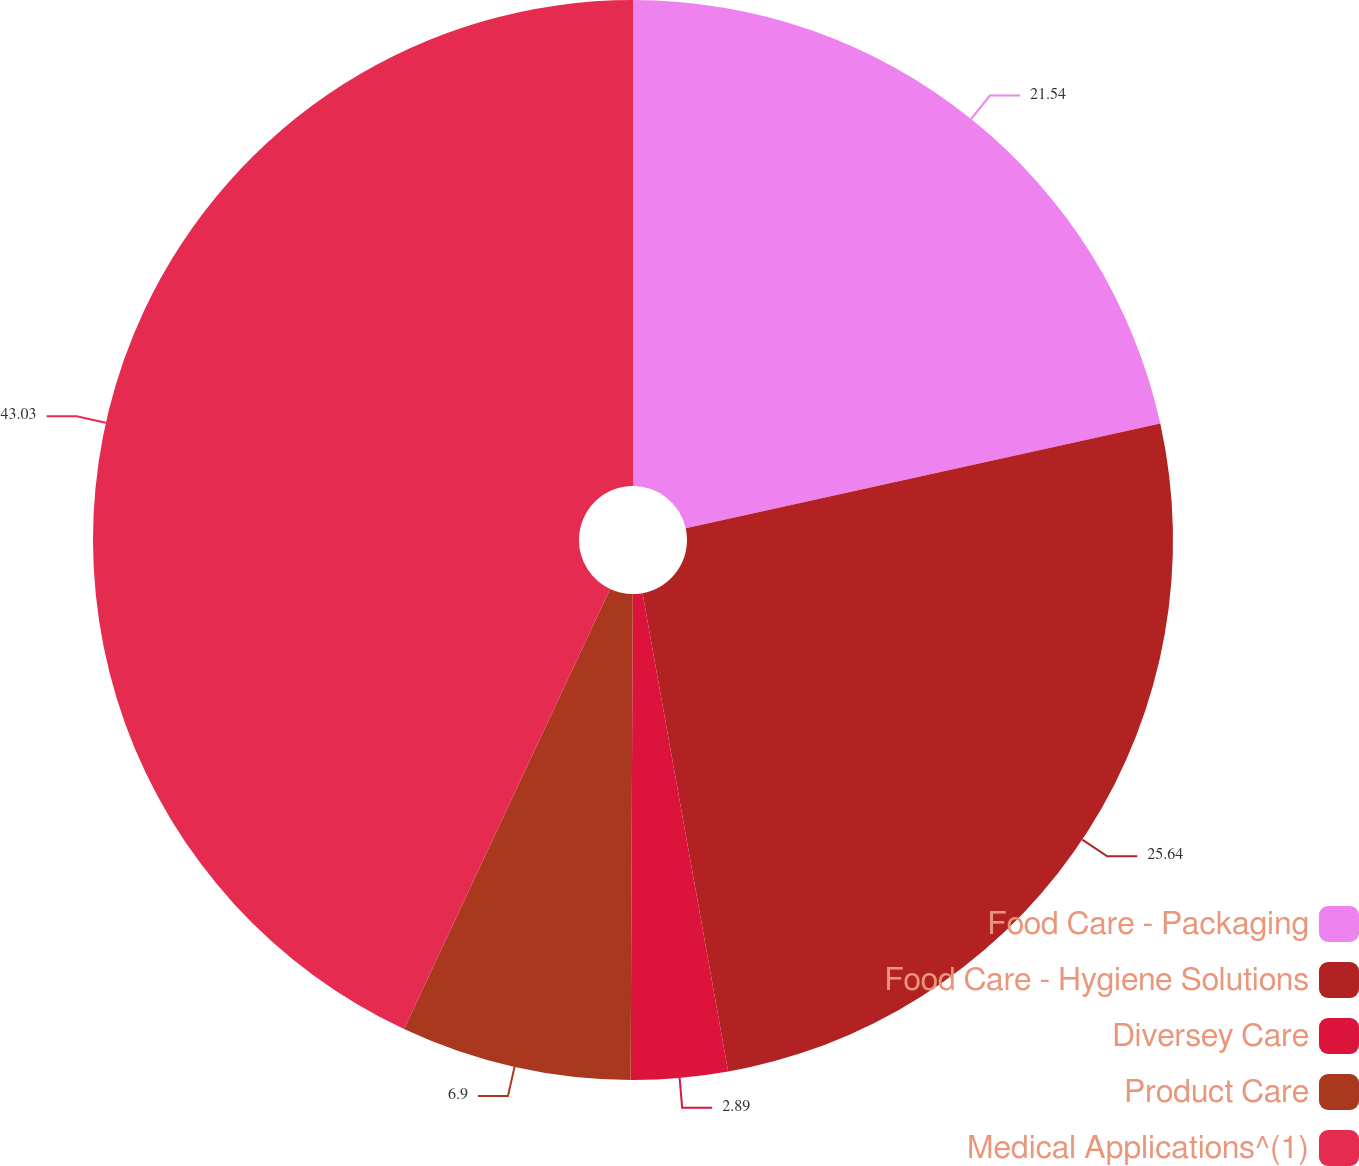<chart> <loc_0><loc_0><loc_500><loc_500><pie_chart><fcel>Food Care - Packaging<fcel>Food Care - Hygiene Solutions<fcel>Diversey Care<fcel>Product Care<fcel>Medical Applications^(1)<nl><fcel>21.54%<fcel>25.64%<fcel>2.89%<fcel>6.9%<fcel>43.03%<nl></chart> 